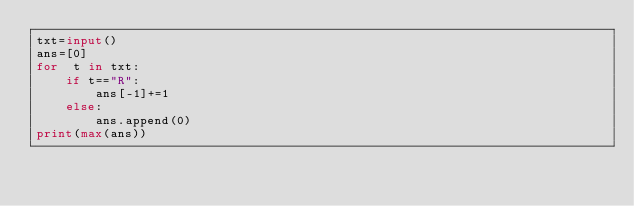<code> <loc_0><loc_0><loc_500><loc_500><_Python_>txt=input()
ans=[0]
for  t in txt:
    if t=="R":
        ans[-1]+=1
    else:
        ans.append(0)
print(max(ans))</code> 